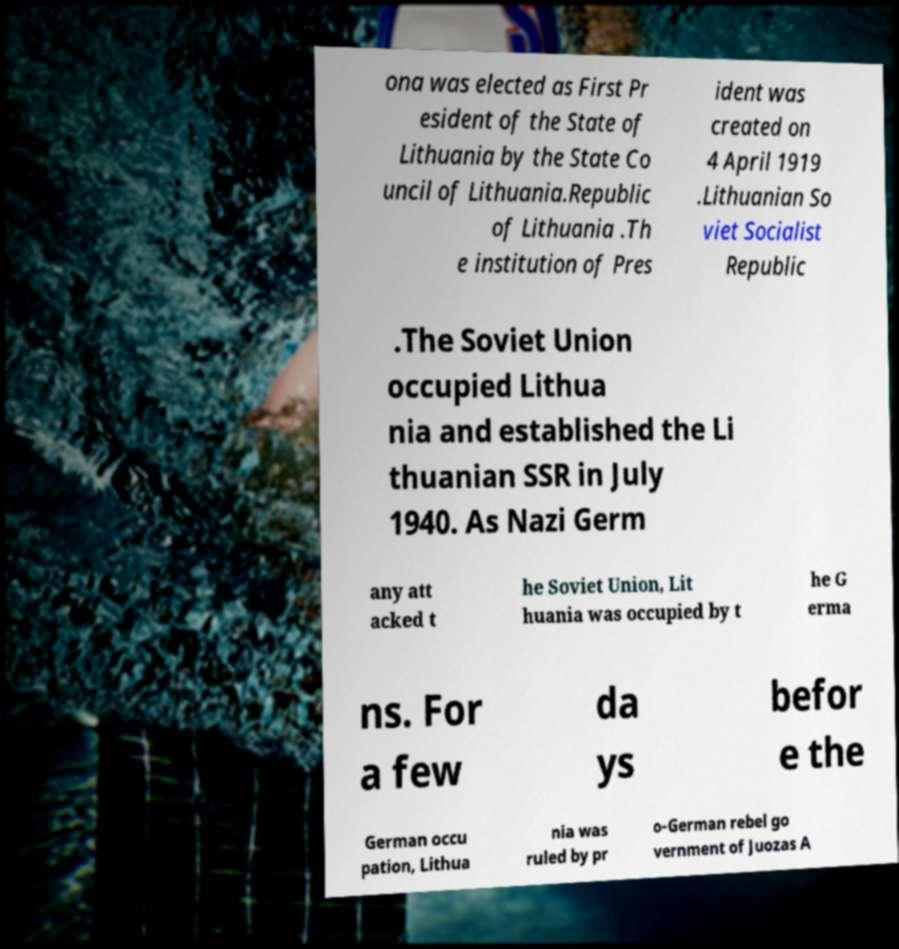I need the written content from this picture converted into text. Can you do that? ona was elected as First Pr esident of the State of Lithuania by the State Co uncil of Lithuania.Republic of Lithuania .Th e institution of Pres ident was created on 4 April 1919 .Lithuanian So viet Socialist Republic .The Soviet Union occupied Lithua nia and established the Li thuanian SSR in July 1940. As Nazi Germ any att acked t he Soviet Union, Lit huania was occupied by t he G erma ns. For a few da ys befor e the German occu pation, Lithua nia was ruled by pr o-German rebel go vernment of Juozas A 